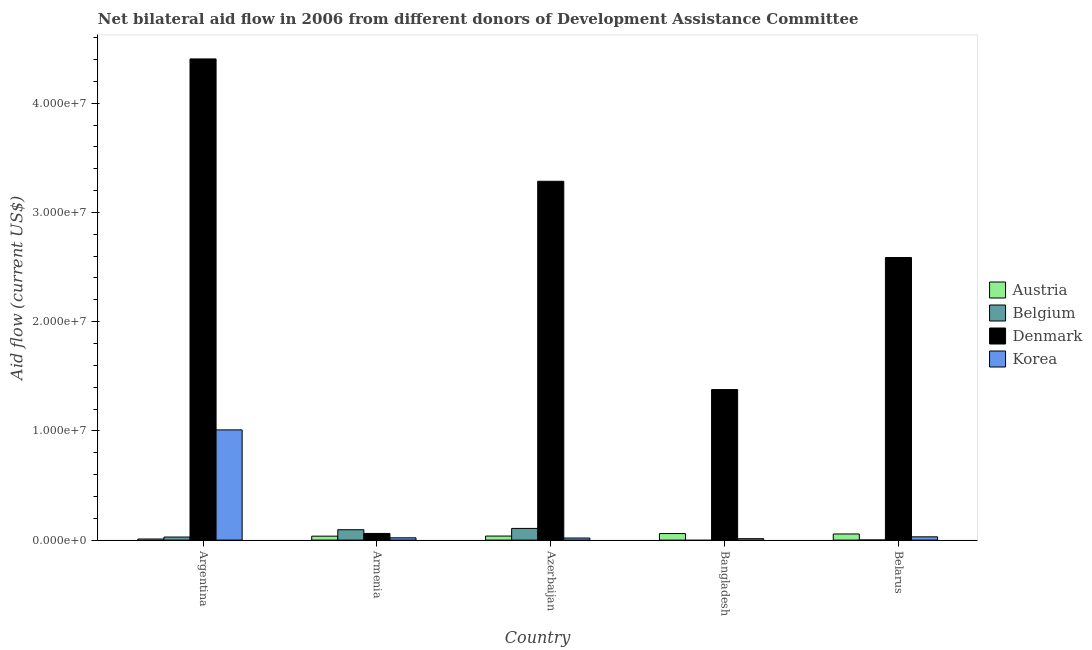Are the number of bars per tick equal to the number of legend labels?
Provide a short and direct response. No. Are the number of bars on each tick of the X-axis equal?
Give a very brief answer. No. What is the label of the 5th group of bars from the left?
Ensure brevity in your answer.  Belarus. What is the amount of aid given by austria in Azerbaijan?
Offer a terse response. 3.70e+05. Across all countries, what is the maximum amount of aid given by belgium?
Your answer should be very brief. 1.07e+06. Across all countries, what is the minimum amount of aid given by austria?
Provide a short and direct response. 1.00e+05. In which country was the amount of aid given by belgium maximum?
Keep it short and to the point. Azerbaijan. What is the total amount of aid given by denmark in the graph?
Your answer should be very brief. 1.17e+08. What is the difference between the amount of aid given by korea in Azerbaijan and that in Bangladesh?
Your answer should be compact. 6.00e+04. What is the difference between the amount of aid given by belgium in Argentina and the amount of aid given by denmark in Azerbaijan?
Give a very brief answer. -3.26e+07. What is the average amount of aid given by korea per country?
Your response must be concise. 2.18e+06. What is the difference between the amount of aid given by austria and amount of aid given by denmark in Belarus?
Give a very brief answer. -2.53e+07. In how many countries, is the amount of aid given by korea greater than 26000000 US$?
Give a very brief answer. 0. What is the ratio of the amount of aid given by austria in Argentina to that in Belarus?
Your response must be concise. 0.18. Is the amount of aid given by austria in Bangladesh less than that in Belarus?
Your response must be concise. No. What is the difference between the highest and the second highest amount of aid given by denmark?
Give a very brief answer. 1.12e+07. What is the difference between the highest and the lowest amount of aid given by denmark?
Keep it short and to the point. 4.34e+07. Is the sum of the amount of aid given by belgium in Armenia and Belarus greater than the maximum amount of aid given by korea across all countries?
Your response must be concise. No. How many bars are there?
Provide a short and direct response. 19. How many countries are there in the graph?
Provide a short and direct response. 5. How many legend labels are there?
Provide a short and direct response. 4. How are the legend labels stacked?
Ensure brevity in your answer.  Vertical. What is the title of the graph?
Provide a succinct answer. Net bilateral aid flow in 2006 from different donors of Development Assistance Committee. What is the Aid flow (current US$) in Austria in Argentina?
Your answer should be compact. 1.00e+05. What is the Aid flow (current US$) in Belgium in Argentina?
Make the answer very short. 2.80e+05. What is the Aid flow (current US$) of Denmark in Argentina?
Provide a short and direct response. 4.40e+07. What is the Aid flow (current US$) in Korea in Argentina?
Make the answer very short. 1.01e+07. What is the Aid flow (current US$) in Belgium in Armenia?
Your response must be concise. 9.50e+05. What is the Aid flow (current US$) in Austria in Azerbaijan?
Your answer should be very brief. 3.70e+05. What is the Aid flow (current US$) of Belgium in Azerbaijan?
Ensure brevity in your answer.  1.07e+06. What is the Aid flow (current US$) in Denmark in Azerbaijan?
Keep it short and to the point. 3.28e+07. What is the Aid flow (current US$) of Austria in Bangladesh?
Give a very brief answer. 6.00e+05. What is the Aid flow (current US$) in Belgium in Bangladesh?
Provide a succinct answer. 0. What is the Aid flow (current US$) of Denmark in Bangladesh?
Offer a very short reply. 1.38e+07. What is the Aid flow (current US$) in Austria in Belarus?
Make the answer very short. 5.60e+05. What is the Aid flow (current US$) of Denmark in Belarus?
Your answer should be compact. 2.59e+07. What is the Aid flow (current US$) in Korea in Belarus?
Ensure brevity in your answer.  3.00e+05. Across all countries, what is the maximum Aid flow (current US$) in Austria?
Provide a succinct answer. 6.00e+05. Across all countries, what is the maximum Aid flow (current US$) of Belgium?
Make the answer very short. 1.07e+06. Across all countries, what is the maximum Aid flow (current US$) of Denmark?
Your response must be concise. 4.40e+07. Across all countries, what is the maximum Aid flow (current US$) of Korea?
Keep it short and to the point. 1.01e+07. Across all countries, what is the minimum Aid flow (current US$) in Korea?
Your answer should be compact. 1.30e+05. What is the total Aid flow (current US$) of Austria in the graph?
Offer a terse response. 1.99e+06. What is the total Aid flow (current US$) in Belgium in the graph?
Make the answer very short. 2.31e+06. What is the total Aid flow (current US$) in Denmark in the graph?
Keep it short and to the point. 1.17e+08. What is the total Aid flow (current US$) of Korea in the graph?
Ensure brevity in your answer.  1.09e+07. What is the difference between the Aid flow (current US$) in Belgium in Argentina and that in Armenia?
Offer a terse response. -6.70e+05. What is the difference between the Aid flow (current US$) of Denmark in Argentina and that in Armenia?
Your response must be concise. 4.34e+07. What is the difference between the Aid flow (current US$) of Korea in Argentina and that in Armenia?
Provide a short and direct response. 9.88e+06. What is the difference between the Aid flow (current US$) of Belgium in Argentina and that in Azerbaijan?
Ensure brevity in your answer.  -7.90e+05. What is the difference between the Aid flow (current US$) of Denmark in Argentina and that in Azerbaijan?
Your answer should be very brief. 1.12e+07. What is the difference between the Aid flow (current US$) in Korea in Argentina and that in Azerbaijan?
Your answer should be very brief. 9.90e+06. What is the difference between the Aid flow (current US$) of Austria in Argentina and that in Bangladesh?
Make the answer very short. -5.00e+05. What is the difference between the Aid flow (current US$) in Denmark in Argentina and that in Bangladesh?
Your response must be concise. 3.03e+07. What is the difference between the Aid flow (current US$) in Korea in Argentina and that in Bangladesh?
Ensure brevity in your answer.  9.96e+06. What is the difference between the Aid flow (current US$) in Austria in Argentina and that in Belarus?
Your answer should be compact. -4.60e+05. What is the difference between the Aid flow (current US$) of Belgium in Argentina and that in Belarus?
Provide a succinct answer. 2.70e+05. What is the difference between the Aid flow (current US$) in Denmark in Argentina and that in Belarus?
Keep it short and to the point. 1.82e+07. What is the difference between the Aid flow (current US$) in Korea in Argentina and that in Belarus?
Offer a terse response. 9.79e+06. What is the difference between the Aid flow (current US$) in Denmark in Armenia and that in Azerbaijan?
Your response must be concise. -3.22e+07. What is the difference between the Aid flow (current US$) in Denmark in Armenia and that in Bangladesh?
Make the answer very short. -1.32e+07. What is the difference between the Aid flow (current US$) of Korea in Armenia and that in Bangladesh?
Give a very brief answer. 8.00e+04. What is the difference between the Aid flow (current US$) of Belgium in Armenia and that in Belarus?
Keep it short and to the point. 9.40e+05. What is the difference between the Aid flow (current US$) of Denmark in Armenia and that in Belarus?
Offer a terse response. -2.53e+07. What is the difference between the Aid flow (current US$) in Korea in Armenia and that in Belarus?
Ensure brevity in your answer.  -9.00e+04. What is the difference between the Aid flow (current US$) of Austria in Azerbaijan and that in Bangladesh?
Ensure brevity in your answer.  -2.30e+05. What is the difference between the Aid flow (current US$) of Denmark in Azerbaijan and that in Bangladesh?
Offer a terse response. 1.91e+07. What is the difference between the Aid flow (current US$) of Korea in Azerbaijan and that in Bangladesh?
Offer a terse response. 6.00e+04. What is the difference between the Aid flow (current US$) of Austria in Azerbaijan and that in Belarus?
Provide a short and direct response. -1.90e+05. What is the difference between the Aid flow (current US$) of Belgium in Azerbaijan and that in Belarus?
Your answer should be compact. 1.06e+06. What is the difference between the Aid flow (current US$) in Denmark in Azerbaijan and that in Belarus?
Provide a succinct answer. 6.98e+06. What is the difference between the Aid flow (current US$) in Denmark in Bangladesh and that in Belarus?
Keep it short and to the point. -1.21e+07. What is the difference between the Aid flow (current US$) in Austria in Argentina and the Aid flow (current US$) in Belgium in Armenia?
Your response must be concise. -8.50e+05. What is the difference between the Aid flow (current US$) of Austria in Argentina and the Aid flow (current US$) of Denmark in Armenia?
Offer a very short reply. -5.10e+05. What is the difference between the Aid flow (current US$) in Austria in Argentina and the Aid flow (current US$) in Korea in Armenia?
Your answer should be compact. -1.10e+05. What is the difference between the Aid flow (current US$) in Belgium in Argentina and the Aid flow (current US$) in Denmark in Armenia?
Your answer should be very brief. -3.30e+05. What is the difference between the Aid flow (current US$) in Belgium in Argentina and the Aid flow (current US$) in Korea in Armenia?
Make the answer very short. 7.00e+04. What is the difference between the Aid flow (current US$) in Denmark in Argentina and the Aid flow (current US$) in Korea in Armenia?
Ensure brevity in your answer.  4.38e+07. What is the difference between the Aid flow (current US$) in Austria in Argentina and the Aid flow (current US$) in Belgium in Azerbaijan?
Keep it short and to the point. -9.70e+05. What is the difference between the Aid flow (current US$) of Austria in Argentina and the Aid flow (current US$) of Denmark in Azerbaijan?
Give a very brief answer. -3.28e+07. What is the difference between the Aid flow (current US$) in Belgium in Argentina and the Aid flow (current US$) in Denmark in Azerbaijan?
Offer a very short reply. -3.26e+07. What is the difference between the Aid flow (current US$) of Belgium in Argentina and the Aid flow (current US$) of Korea in Azerbaijan?
Your response must be concise. 9.00e+04. What is the difference between the Aid flow (current US$) of Denmark in Argentina and the Aid flow (current US$) of Korea in Azerbaijan?
Provide a succinct answer. 4.39e+07. What is the difference between the Aid flow (current US$) in Austria in Argentina and the Aid flow (current US$) in Denmark in Bangladesh?
Offer a terse response. -1.37e+07. What is the difference between the Aid flow (current US$) of Belgium in Argentina and the Aid flow (current US$) of Denmark in Bangladesh?
Your answer should be compact. -1.35e+07. What is the difference between the Aid flow (current US$) in Belgium in Argentina and the Aid flow (current US$) in Korea in Bangladesh?
Ensure brevity in your answer.  1.50e+05. What is the difference between the Aid flow (current US$) in Denmark in Argentina and the Aid flow (current US$) in Korea in Bangladesh?
Make the answer very short. 4.39e+07. What is the difference between the Aid flow (current US$) of Austria in Argentina and the Aid flow (current US$) of Belgium in Belarus?
Offer a terse response. 9.00e+04. What is the difference between the Aid flow (current US$) of Austria in Argentina and the Aid flow (current US$) of Denmark in Belarus?
Your answer should be very brief. -2.58e+07. What is the difference between the Aid flow (current US$) in Austria in Argentina and the Aid flow (current US$) in Korea in Belarus?
Ensure brevity in your answer.  -2.00e+05. What is the difference between the Aid flow (current US$) of Belgium in Argentina and the Aid flow (current US$) of Denmark in Belarus?
Offer a terse response. -2.56e+07. What is the difference between the Aid flow (current US$) of Denmark in Argentina and the Aid flow (current US$) of Korea in Belarus?
Provide a succinct answer. 4.38e+07. What is the difference between the Aid flow (current US$) of Austria in Armenia and the Aid flow (current US$) of Belgium in Azerbaijan?
Ensure brevity in your answer.  -7.10e+05. What is the difference between the Aid flow (current US$) in Austria in Armenia and the Aid flow (current US$) in Denmark in Azerbaijan?
Provide a succinct answer. -3.25e+07. What is the difference between the Aid flow (current US$) in Austria in Armenia and the Aid flow (current US$) in Korea in Azerbaijan?
Offer a terse response. 1.70e+05. What is the difference between the Aid flow (current US$) of Belgium in Armenia and the Aid flow (current US$) of Denmark in Azerbaijan?
Your answer should be compact. -3.19e+07. What is the difference between the Aid flow (current US$) in Belgium in Armenia and the Aid flow (current US$) in Korea in Azerbaijan?
Your answer should be compact. 7.60e+05. What is the difference between the Aid flow (current US$) of Denmark in Armenia and the Aid flow (current US$) of Korea in Azerbaijan?
Keep it short and to the point. 4.20e+05. What is the difference between the Aid flow (current US$) of Austria in Armenia and the Aid flow (current US$) of Denmark in Bangladesh?
Provide a short and direct response. -1.34e+07. What is the difference between the Aid flow (current US$) of Austria in Armenia and the Aid flow (current US$) of Korea in Bangladesh?
Keep it short and to the point. 2.30e+05. What is the difference between the Aid flow (current US$) in Belgium in Armenia and the Aid flow (current US$) in Denmark in Bangladesh?
Ensure brevity in your answer.  -1.28e+07. What is the difference between the Aid flow (current US$) in Belgium in Armenia and the Aid flow (current US$) in Korea in Bangladesh?
Provide a succinct answer. 8.20e+05. What is the difference between the Aid flow (current US$) of Denmark in Armenia and the Aid flow (current US$) of Korea in Bangladesh?
Offer a very short reply. 4.80e+05. What is the difference between the Aid flow (current US$) in Austria in Armenia and the Aid flow (current US$) in Denmark in Belarus?
Your answer should be compact. -2.55e+07. What is the difference between the Aid flow (current US$) in Austria in Armenia and the Aid flow (current US$) in Korea in Belarus?
Make the answer very short. 6.00e+04. What is the difference between the Aid flow (current US$) in Belgium in Armenia and the Aid flow (current US$) in Denmark in Belarus?
Your response must be concise. -2.49e+07. What is the difference between the Aid flow (current US$) in Belgium in Armenia and the Aid flow (current US$) in Korea in Belarus?
Give a very brief answer. 6.50e+05. What is the difference between the Aid flow (current US$) of Austria in Azerbaijan and the Aid flow (current US$) of Denmark in Bangladesh?
Offer a very short reply. -1.34e+07. What is the difference between the Aid flow (current US$) in Austria in Azerbaijan and the Aid flow (current US$) in Korea in Bangladesh?
Your answer should be very brief. 2.40e+05. What is the difference between the Aid flow (current US$) in Belgium in Azerbaijan and the Aid flow (current US$) in Denmark in Bangladesh?
Offer a very short reply. -1.27e+07. What is the difference between the Aid flow (current US$) in Belgium in Azerbaijan and the Aid flow (current US$) in Korea in Bangladesh?
Your response must be concise. 9.40e+05. What is the difference between the Aid flow (current US$) of Denmark in Azerbaijan and the Aid flow (current US$) of Korea in Bangladesh?
Make the answer very short. 3.27e+07. What is the difference between the Aid flow (current US$) of Austria in Azerbaijan and the Aid flow (current US$) of Belgium in Belarus?
Ensure brevity in your answer.  3.60e+05. What is the difference between the Aid flow (current US$) in Austria in Azerbaijan and the Aid flow (current US$) in Denmark in Belarus?
Offer a very short reply. -2.55e+07. What is the difference between the Aid flow (current US$) of Belgium in Azerbaijan and the Aid flow (current US$) of Denmark in Belarus?
Keep it short and to the point. -2.48e+07. What is the difference between the Aid flow (current US$) in Belgium in Azerbaijan and the Aid flow (current US$) in Korea in Belarus?
Your answer should be compact. 7.70e+05. What is the difference between the Aid flow (current US$) in Denmark in Azerbaijan and the Aid flow (current US$) in Korea in Belarus?
Offer a terse response. 3.26e+07. What is the difference between the Aid flow (current US$) in Austria in Bangladesh and the Aid flow (current US$) in Belgium in Belarus?
Make the answer very short. 5.90e+05. What is the difference between the Aid flow (current US$) in Austria in Bangladesh and the Aid flow (current US$) in Denmark in Belarus?
Your answer should be compact. -2.53e+07. What is the difference between the Aid flow (current US$) in Austria in Bangladesh and the Aid flow (current US$) in Korea in Belarus?
Offer a terse response. 3.00e+05. What is the difference between the Aid flow (current US$) in Denmark in Bangladesh and the Aid flow (current US$) in Korea in Belarus?
Give a very brief answer. 1.35e+07. What is the average Aid flow (current US$) of Austria per country?
Ensure brevity in your answer.  3.98e+05. What is the average Aid flow (current US$) of Belgium per country?
Make the answer very short. 4.62e+05. What is the average Aid flow (current US$) of Denmark per country?
Offer a terse response. 2.34e+07. What is the average Aid flow (current US$) in Korea per country?
Your answer should be very brief. 2.18e+06. What is the difference between the Aid flow (current US$) of Austria and Aid flow (current US$) of Belgium in Argentina?
Ensure brevity in your answer.  -1.80e+05. What is the difference between the Aid flow (current US$) of Austria and Aid flow (current US$) of Denmark in Argentina?
Provide a succinct answer. -4.40e+07. What is the difference between the Aid flow (current US$) in Austria and Aid flow (current US$) in Korea in Argentina?
Give a very brief answer. -9.99e+06. What is the difference between the Aid flow (current US$) of Belgium and Aid flow (current US$) of Denmark in Argentina?
Ensure brevity in your answer.  -4.38e+07. What is the difference between the Aid flow (current US$) of Belgium and Aid flow (current US$) of Korea in Argentina?
Your answer should be very brief. -9.81e+06. What is the difference between the Aid flow (current US$) in Denmark and Aid flow (current US$) in Korea in Argentina?
Provide a succinct answer. 3.40e+07. What is the difference between the Aid flow (current US$) in Austria and Aid flow (current US$) in Belgium in Armenia?
Offer a very short reply. -5.90e+05. What is the difference between the Aid flow (current US$) in Austria and Aid flow (current US$) in Korea in Armenia?
Offer a very short reply. 1.50e+05. What is the difference between the Aid flow (current US$) of Belgium and Aid flow (current US$) of Denmark in Armenia?
Provide a short and direct response. 3.40e+05. What is the difference between the Aid flow (current US$) of Belgium and Aid flow (current US$) of Korea in Armenia?
Your answer should be very brief. 7.40e+05. What is the difference between the Aid flow (current US$) in Austria and Aid flow (current US$) in Belgium in Azerbaijan?
Provide a short and direct response. -7.00e+05. What is the difference between the Aid flow (current US$) in Austria and Aid flow (current US$) in Denmark in Azerbaijan?
Keep it short and to the point. -3.25e+07. What is the difference between the Aid flow (current US$) of Austria and Aid flow (current US$) of Korea in Azerbaijan?
Provide a short and direct response. 1.80e+05. What is the difference between the Aid flow (current US$) of Belgium and Aid flow (current US$) of Denmark in Azerbaijan?
Your answer should be compact. -3.18e+07. What is the difference between the Aid flow (current US$) of Belgium and Aid flow (current US$) of Korea in Azerbaijan?
Provide a succinct answer. 8.80e+05. What is the difference between the Aid flow (current US$) of Denmark and Aid flow (current US$) of Korea in Azerbaijan?
Provide a succinct answer. 3.27e+07. What is the difference between the Aid flow (current US$) in Austria and Aid flow (current US$) in Denmark in Bangladesh?
Your answer should be compact. -1.32e+07. What is the difference between the Aid flow (current US$) in Denmark and Aid flow (current US$) in Korea in Bangladesh?
Provide a short and direct response. 1.36e+07. What is the difference between the Aid flow (current US$) of Austria and Aid flow (current US$) of Belgium in Belarus?
Ensure brevity in your answer.  5.50e+05. What is the difference between the Aid flow (current US$) in Austria and Aid flow (current US$) in Denmark in Belarus?
Offer a terse response. -2.53e+07. What is the difference between the Aid flow (current US$) of Austria and Aid flow (current US$) of Korea in Belarus?
Your answer should be very brief. 2.60e+05. What is the difference between the Aid flow (current US$) in Belgium and Aid flow (current US$) in Denmark in Belarus?
Give a very brief answer. -2.59e+07. What is the difference between the Aid flow (current US$) of Belgium and Aid flow (current US$) of Korea in Belarus?
Your answer should be compact. -2.90e+05. What is the difference between the Aid flow (current US$) of Denmark and Aid flow (current US$) of Korea in Belarus?
Your response must be concise. 2.56e+07. What is the ratio of the Aid flow (current US$) in Austria in Argentina to that in Armenia?
Provide a short and direct response. 0.28. What is the ratio of the Aid flow (current US$) in Belgium in Argentina to that in Armenia?
Offer a terse response. 0.29. What is the ratio of the Aid flow (current US$) of Denmark in Argentina to that in Armenia?
Make the answer very short. 72.21. What is the ratio of the Aid flow (current US$) of Korea in Argentina to that in Armenia?
Provide a succinct answer. 48.05. What is the ratio of the Aid flow (current US$) of Austria in Argentina to that in Azerbaijan?
Give a very brief answer. 0.27. What is the ratio of the Aid flow (current US$) in Belgium in Argentina to that in Azerbaijan?
Provide a succinct answer. 0.26. What is the ratio of the Aid flow (current US$) of Denmark in Argentina to that in Azerbaijan?
Provide a succinct answer. 1.34. What is the ratio of the Aid flow (current US$) of Korea in Argentina to that in Azerbaijan?
Your answer should be very brief. 53.11. What is the ratio of the Aid flow (current US$) in Denmark in Argentina to that in Bangladesh?
Provide a short and direct response. 3.2. What is the ratio of the Aid flow (current US$) of Korea in Argentina to that in Bangladesh?
Keep it short and to the point. 77.62. What is the ratio of the Aid flow (current US$) in Austria in Argentina to that in Belarus?
Your response must be concise. 0.18. What is the ratio of the Aid flow (current US$) in Denmark in Argentina to that in Belarus?
Provide a short and direct response. 1.7. What is the ratio of the Aid flow (current US$) in Korea in Argentina to that in Belarus?
Provide a short and direct response. 33.63. What is the ratio of the Aid flow (current US$) in Austria in Armenia to that in Azerbaijan?
Give a very brief answer. 0.97. What is the ratio of the Aid flow (current US$) of Belgium in Armenia to that in Azerbaijan?
Make the answer very short. 0.89. What is the ratio of the Aid flow (current US$) in Denmark in Armenia to that in Azerbaijan?
Your answer should be compact. 0.02. What is the ratio of the Aid flow (current US$) of Korea in Armenia to that in Azerbaijan?
Give a very brief answer. 1.11. What is the ratio of the Aid flow (current US$) of Austria in Armenia to that in Bangladesh?
Your answer should be compact. 0.6. What is the ratio of the Aid flow (current US$) in Denmark in Armenia to that in Bangladesh?
Your answer should be very brief. 0.04. What is the ratio of the Aid flow (current US$) of Korea in Armenia to that in Bangladesh?
Your response must be concise. 1.62. What is the ratio of the Aid flow (current US$) in Austria in Armenia to that in Belarus?
Give a very brief answer. 0.64. What is the ratio of the Aid flow (current US$) in Denmark in Armenia to that in Belarus?
Provide a succinct answer. 0.02. What is the ratio of the Aid flow (current US$) in Austria in Azerbaijan to that in Bangladesh?
Your answer should be very brief. 0.62. What is the ratio of the Aid flow (current US$) of Denmark in Azerbaijan to that in Bangladesh?
Your answer should be very brief. 2.38. What is the ratio of the Aid flow (current US$) in Korea in Azerbaijan to that in Bangladesh?
Your answer should be very brief. 1.46. What is the ratio of the Aid flow (current US$) in Austria in Azerbaijan to that in Belarus?
Offer a terse response. 0.66. What is the ratio of the Aid flow (current US$) in Belgium in Azerbaijan to that in Belarus?
Provide a succinct answer. 107. What is the ratio of the Aid flow (current US$) of Denmark in Azerbaijan to that in Belarus?
Offer a terse response. 1.27. What is the ratio of the Aid flow (current US$) in Korea in Azerbaijan to that in Belarus?
Your answer should be very brief. 0.63. What is the ratio of the Aid flow (current US$) of Austria in Bangladesh to that in Belarus?
Your answer should be very brief. 1.07. What is the ratio of the Aid flow (current US$) in Denmark in Bangladesh to that in Belarus?
Your answer should be compact. 0.53. What is the ratio of the Aid flow (current US$) of Korea in Bangladesh to that in Belarus?
Your answer should be compact. 0.43. What is the difference between the highest and the second highest Aid flow (current US$) in Austria?
Your answer should be compact. 4.00e+04. What is the difference between the highest and the second highest Aid flow (current US$) of Denmark?
Give a very brief answer. 1.12e+07. What is the difference between the highest and the second highest Aid flow (current US$) of Korea?
Ensure brevity in your answer.  9.79e+06. What is the difference between the highest and the lowest Aid flow (current US$) of Belgium?
Your response must be concise. 1.07e+06. What is the difference between the highest and the lowest Aid flow (current US$) of Denmark?
Offer a terse response. 4.34e+07. What is the difference between the highest and the lowest Aid flow (current US$) of Korea?
Your answer should be compact. 9.96e+06. 